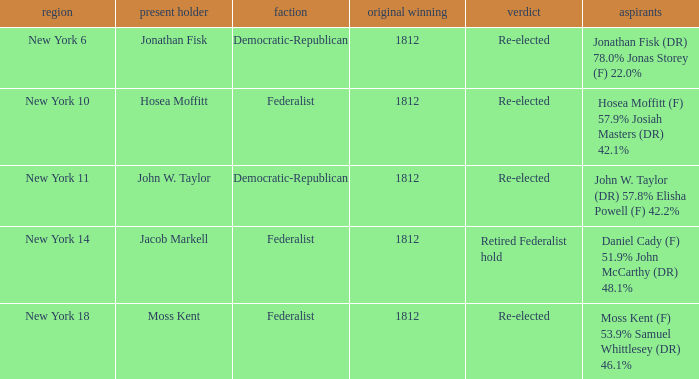Name the least first elected 1812.0. Help me parse the entirety of this table. {'header': ['region', 'present holder', 'faction', 'original winning', 'verdict', 'aspirants'], 'rows': [['New York 6', 'Jonathan Fisk', 'Democratic-Republican', '1812', 'Re-elected', 'Jonathan Fisk (DR) 78.0% Jonas Storey (F) 22.0%'], ['New York 10', 'Hosea Moffitt', 'Federalist', '1812', 'Re-elected', 'Hosea Moffitt (F) 57.9% Josiah Masters (DR) 42.1%'], ['New York 11', 'John W. Taylor', 'Democratic-Republican', '1812', 'Re-elected', 'John W. Taylor (DR) 57.8% Elisha Powell (F) 42.2%'], ['New York 14', 'Jacob Markell', 'Federalist', '1812', 'Retired Federalist hold', 'Daniel Cady (F) 51.9% John McCarthy (DR) 48.1%'], ['New York 18', 'Moss Kent', 'Federalist', '1812', 'Re-elected', 'Moss Kent (F) 53.9% Samuel Whittlesey (DR) 46.1%']]} 